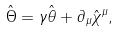Convert formula to latex. <formula><loc_0><loc_0><loc_500><loc_500>\hat { \Theta } = \gamma \hat { \theta } + \partial _ { \mu } \hat { \chi } ^ { \mu } ,</formula> 